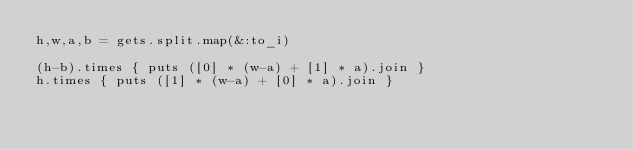Convert code to text. <code><loc_0><loc_0><loc_500><loc_500><_Ruby_>h,w,a,b = gets.split.map(&:to_i)

(h-b).times { puts ([0] * (w-a) + [1] * a).join }
h.times { puts ([1] * (w-a) + [0] * a).join }</code> 